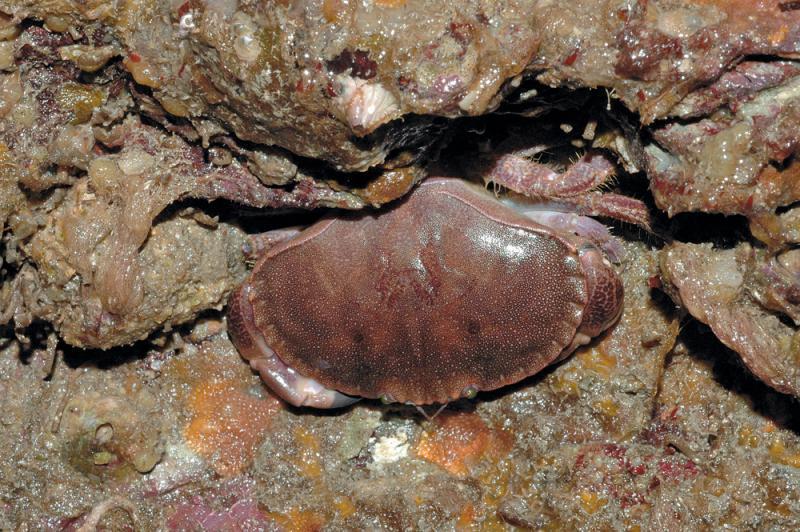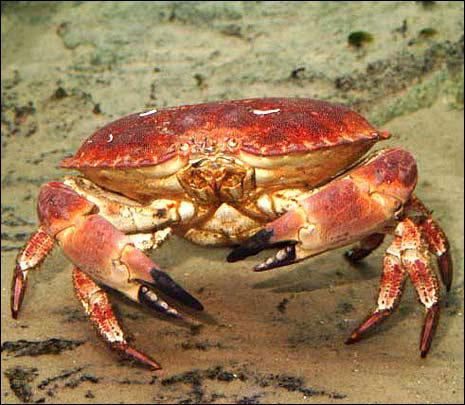The first image is the image on the left, the second image is the image on the right. For the images shown, is this caption "The tips of every crab's claws are noticeably black." true? Answer yes or no. No. The first image is the image on the left, the second image is the image on the right. Considering the images on both sides, is "Each image shows one purple crab with dark-tipped front claws that is facing the camera." valid? Answer yes or no. No. 